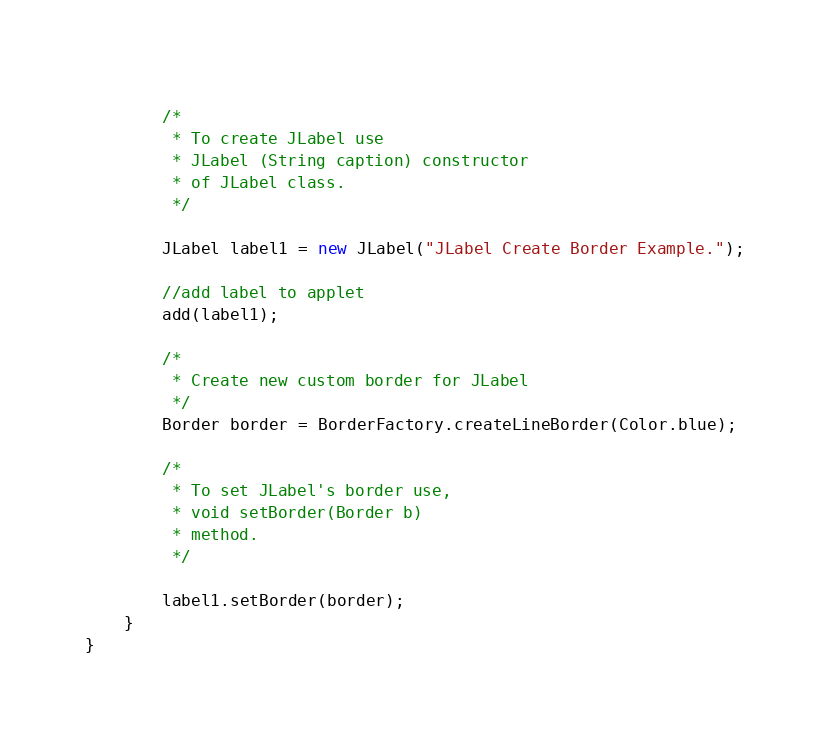Convert code to text. <code><loc_0><loc_0><loc_500><loc_500><_Java_>		
		/*
		 * To create JLabel use 
		 * JLabel (String caption) constructor
		 * of JLabel class.
		 */
		
		JLabel label1 = new JLabel("JLabel Create Border Example.");
			
		//add label to applet
		add(label1);
		
		/*
		 * Create new custom border for JLabel
		 */
		Border border = BorderFactory.createLineBorder(Color.blue);
		
		/*
		 * To set JLabel's border use,
		 * void setBorder(Border b)
		 * method.
		 */
		
		label1.setBorder(border);
	}
}</code> 